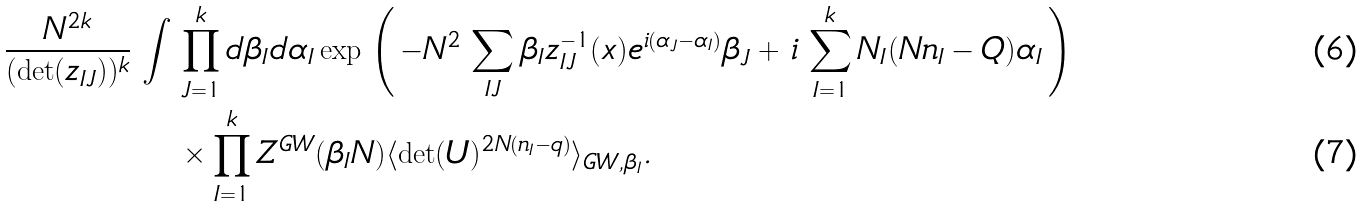Convert formula to latex. <formula><loc_0><loc_0><loc_500><loc_500>\, \frac { N ^ { 2 k } } { ( \det ( z _ { I J } ) ) ^ { k } } \, \int \, & \prod _ { J = 1 } ^ { k } d \beta _ { I } d \alpha _ { I } \exp \, \left ( \, - N ^ { 2 } \, \sum _ { I J } \beta _ { I } z ^ { - 1 } _ { I J } ( x ) e ^ { i ( \alpha _ { J } - \alpha _ { I } ) } \beta _ { J } + \, i \, \sum _ { I = 1 } ^ { k } N _ { I } ( N n _ { I } - Q ) \alpha _ { I } \, \right ) \\ & \times \prod _ { I = 1 } ^ { k } Z ^ { G W } ( \beta _ { I } N ) \langle \det ( U ) ^ { 2 N ( n _ { I } - q ) } \rangle _ { G W , \beta _ { I } } .</formula> 